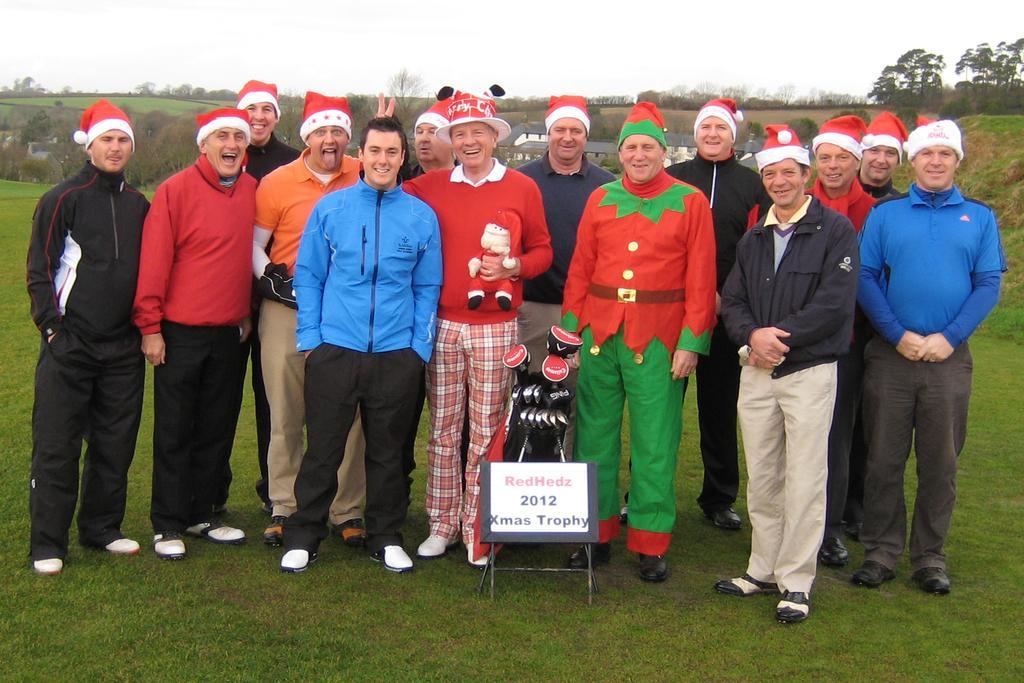Could you give a brief overview of what you see in this image? In this image there are group of boys who are standing on the ground. All the boys are wearing a Christmas cap. In front of them there is a trophy. In the background there are small plants and grass. 